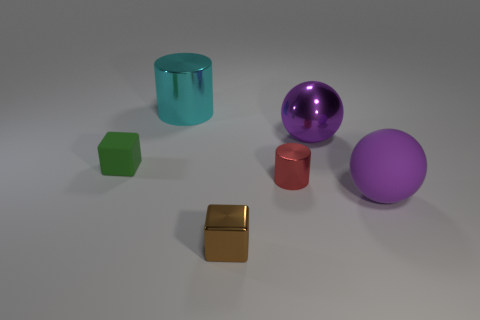Does the tiny metallic block have the same color as the large metal sphere?
Offer a terse response. No. How many red metallic things have the same size as the purple metal object?
Ensure brevity in your answer.  0. What is the shape of the small red object?
Make the answer very short. Cylinder. What is the size of the thing that is both behind the tiny red metallic object and to the right of the cyan shiny object?
Give a very brief answer. Large. What material is the small object to the left of the brown cube?
Your answer should be very brief. Rubber. There is a tiny metal cylinder; is it the same color as the large metal thing that is right of the small red metal object?
Offer a very short reply. No. How many things are matte things to the left of the small brown block or purple objects behind the brown block?
Your response must be concise. 3. What color is the shiny thing that is behind the purple rubber object and in front of the purple metal ball?
Ensure brevity in your answer.  Red. Are there more big purple things than purple shiny balls?
Give a very brief answer. Yes. There is a tiny thing that is on the right side of the tiny shiny cube; is it the same shape as the tiny green object?
Give a very brief answer. No. 